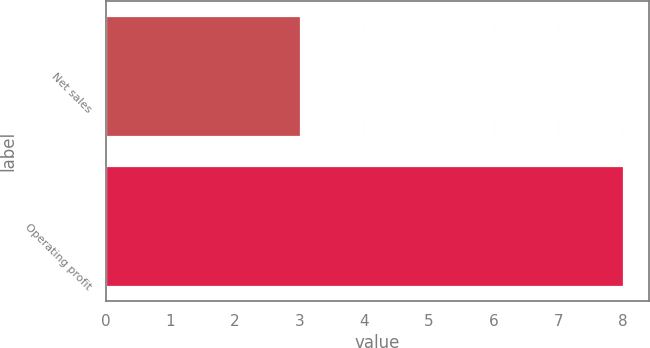<chart> <loc_0><loc_0><loc_500><loc_500><bar_chart><fcel>Net sales<fcel>Operating profit<nl><fcel>3<fcel>8<nl></chart> 